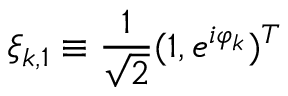<formula> <loc_0><loc_0><loc_500><loc_500>\xi _ { k , 1 } \equiv \frac { 1 } { \sqrt { 2 } } ( 1 , e ^ { i \varphi _ { k } } ) ^ { T }</formula> 